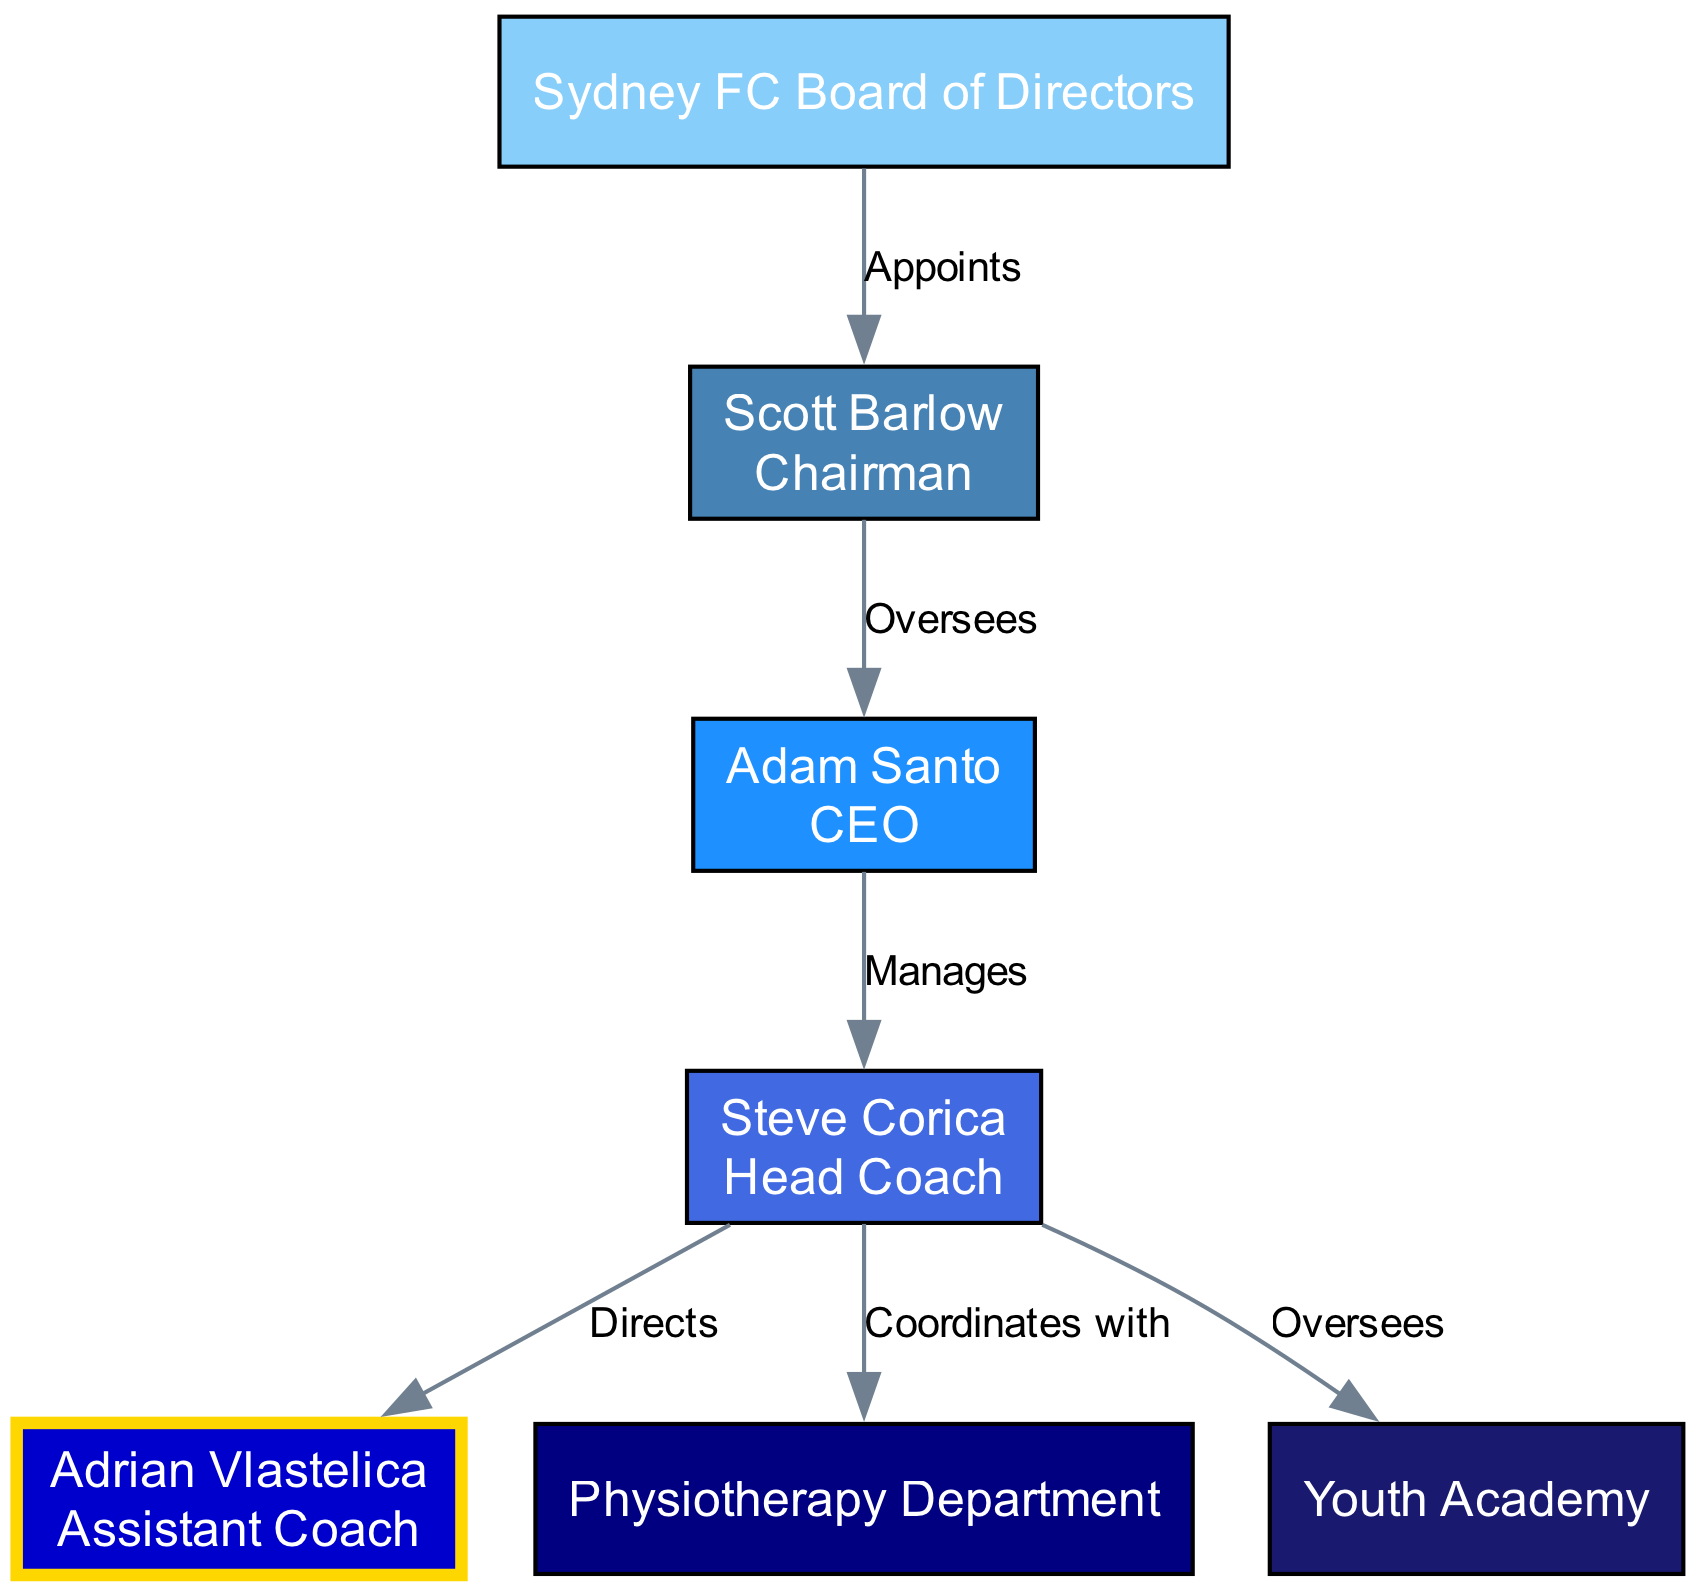What is the role of Scott Barlow in Sydney FC's management? The diagram indicates that Scott Barlow is labeled as the "Chairman". This is explicitly stated in his node description.
Answer: Chairman Who does the CEO oversee? The diagram shows that the edge connecting Scott Barlow (Chairman) to Adam Santo (CEO) is labeled "Oversees", meaning the CEO is overseen by the Chairman. Therefore, the CEO oversees the Head Coach, Steve Corica, as indicated by the edge labeled "Manages" stemming from the CEO's node to the Head Coach's node.
Answer: Head Coach How many nodes are there in the diagram? The diagram lists a total of 7 unique nodes, each representing a different role or department in Sydney FC's organizational structure. This is confirmed by counting the number of nodes provided in the 'nodes' section of the data.
Answer: 7 What action does the Head Coach take towards the Youth Academy? The diagram illustrates that the Head Coach, Steve Corica, has a direct relationship with the Youth Academy labeled as "Oversees". This points to the Head Coach exerting oversight over the Youth Academy.
Answer: Oversees Who is directly below the Head Coach in the organizational hierarchy? The diagram shows that the Head Coach, Steve Corica, has a directed edge connecting to Adrian Vlastelica (Assistant Coach) labeled "Directs". This means that the Assistant Coach is directly managed by the Head Coach, indicating a hierarchical relationship.
Answer: Assistant Coach What department does the Head Coach coordinate with? The diagram indicates an edge between the Head Coach's node and the Physiotherapy Department, labeled "Coordinates with". This clearly specifies that the Head Coach coordinates activities with the Physiotherapy Department as part of the organization.
Answer: Physiotherapy Department Who appoints the Chairman? An edge in the diagram connects the Sydney FC Board of Directors to Scott Barlow (Chairman) labeled "Appoints". This conveys that the Board of Directors holds the authority to appoint the Chairman, thus answering the question directly.
Answer: Sydney FC Board of Directors How many edges are present in the diagram? By inspecting the diagram's edges, it is noted that there are 6 connections, each representing a distinct relationship or action between the entities in the organizational structure. These connections can be counted directly from the 'edges' section in the data.
Answer: 6 